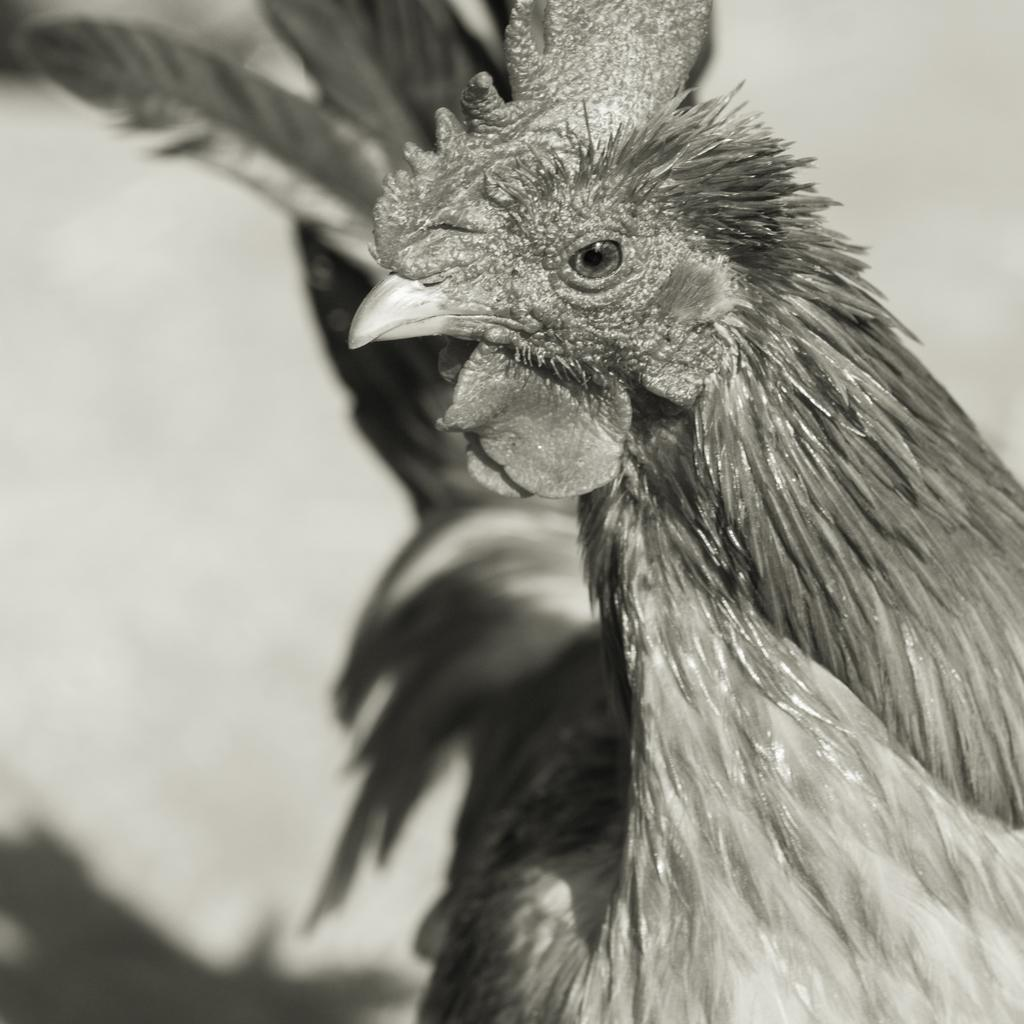What type of animal is present in the image? There is a hen in the image. What type of cabbage is being used as a hat by the hen in the image? There is no cabbage present in the image, nor is the hen wearing a hat. 